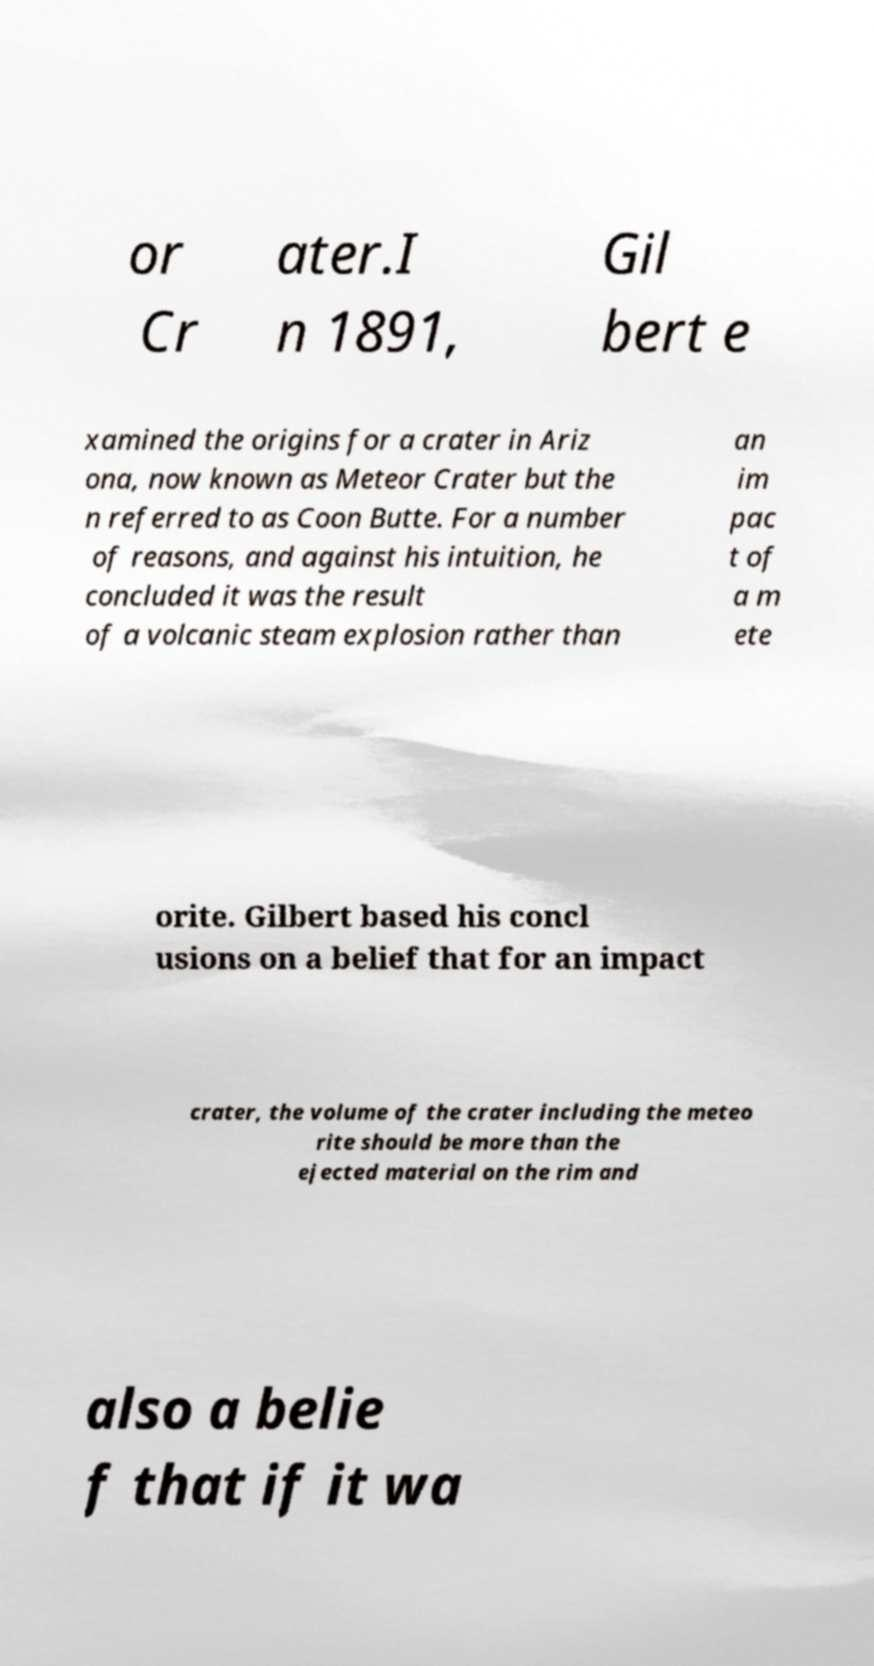Could you extract and type out the text from this image? or Cr ater.I n 1891, Gil bert e xamined the origins for a crater in Ariz ona, now known as Meteor Crater but the n referred to as Coon Butte. For a number of reasons, and against his intuition, he concluded it was the result of a volcanic steam explosion rather than an im pac t of a m ete orite. Gilbert based his concl usions on a belief that for an impact crater, the volume of the crater including the meteo rite should be more than the ejected material on the rim and also a belie f that if it wa 